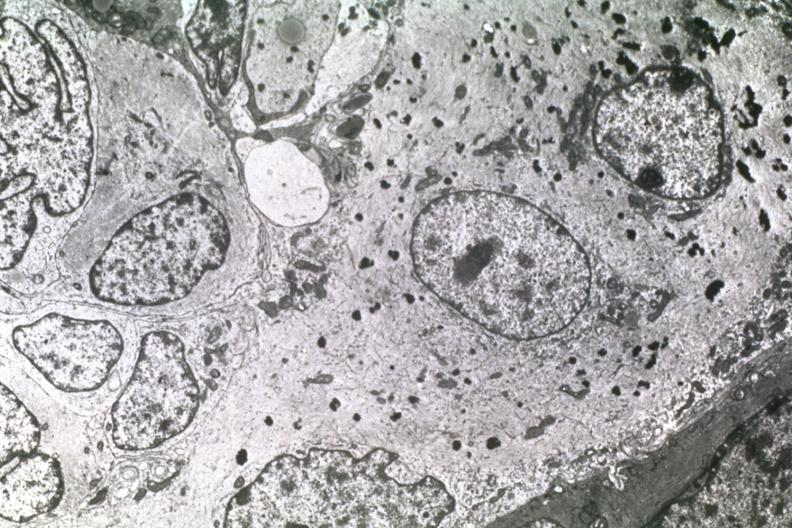what does this image show?
Answer the question using a single word or phrase. Dr garcia tumors 25 